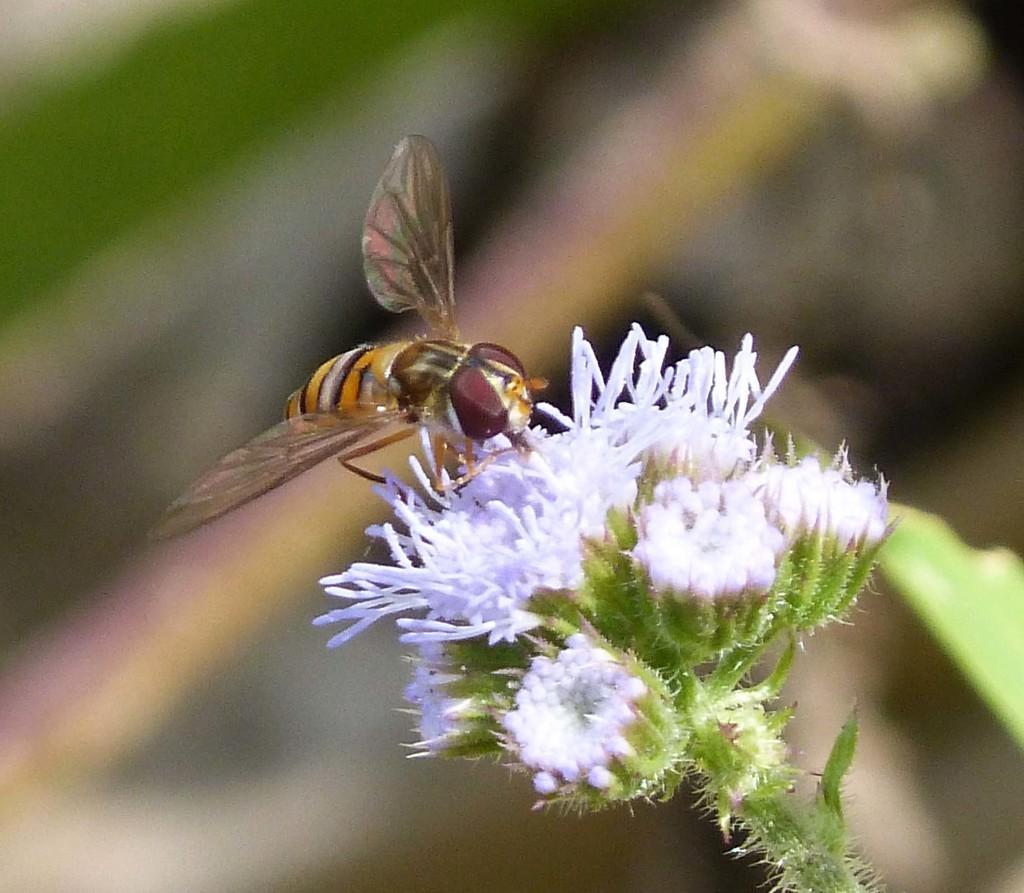Describe this image in one or two sentences. In this image I can see a flower to a stem. On the flower there is a bee. The background is blurred. 